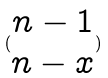<formula> <loc_0><loc_0><loc_500><loc_500>( \begin{matrix} n - 1 \\ n - x \end{matrix} )</formula> 